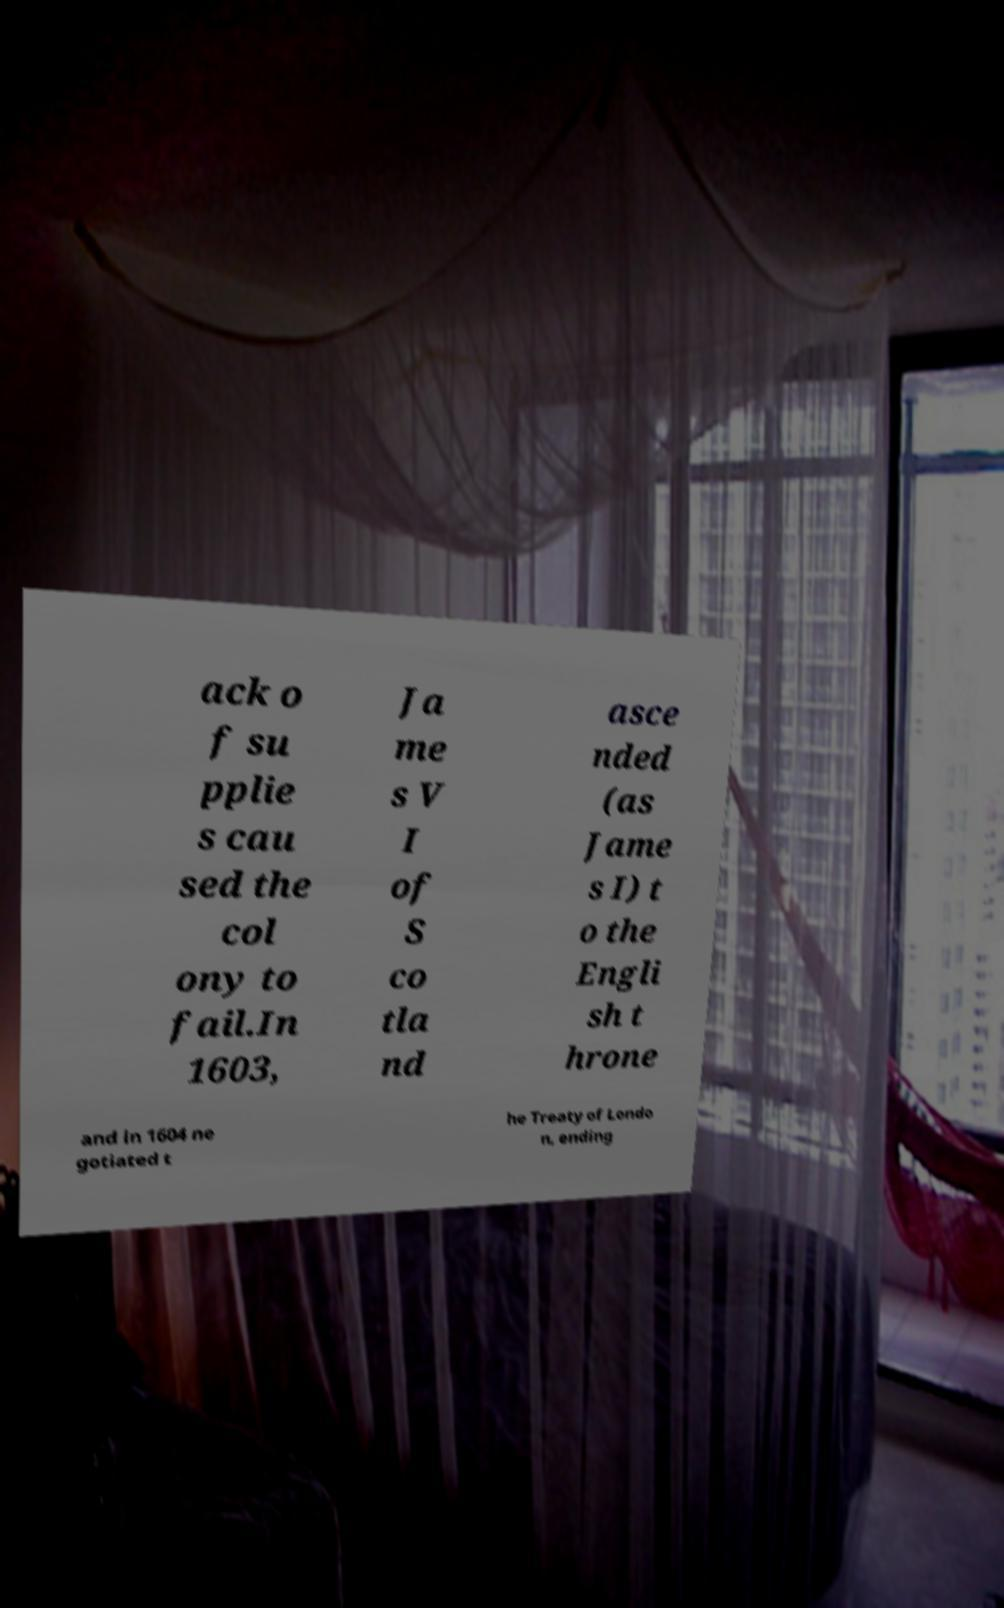Can you read and provide the text displayed in the image?This photo seems to have some interesting text. Can you extract and type it out for me? ack o f su pplie s cau sed the col ony to fail.In 1603, Ja me s V I of S co tla nd asce nded (as Jame s I) t o the Engli sh t hrone and in 1604 ne gotiated t he Treaty of Londo n, ending 